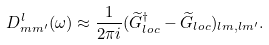<formula> <loc_0><loc_0><loc_500><loc_500>D ^ { l } _ { m m ^ { \prime } } ( \omega ) \approx \frac { 1 } { 2 \pi i } ( \widetilde { G } ^ { \dagger } _ { l o c } - \widetilde { G } _ { l o c } ) _ { l m , l m ^ { \prime } } .</formula> 